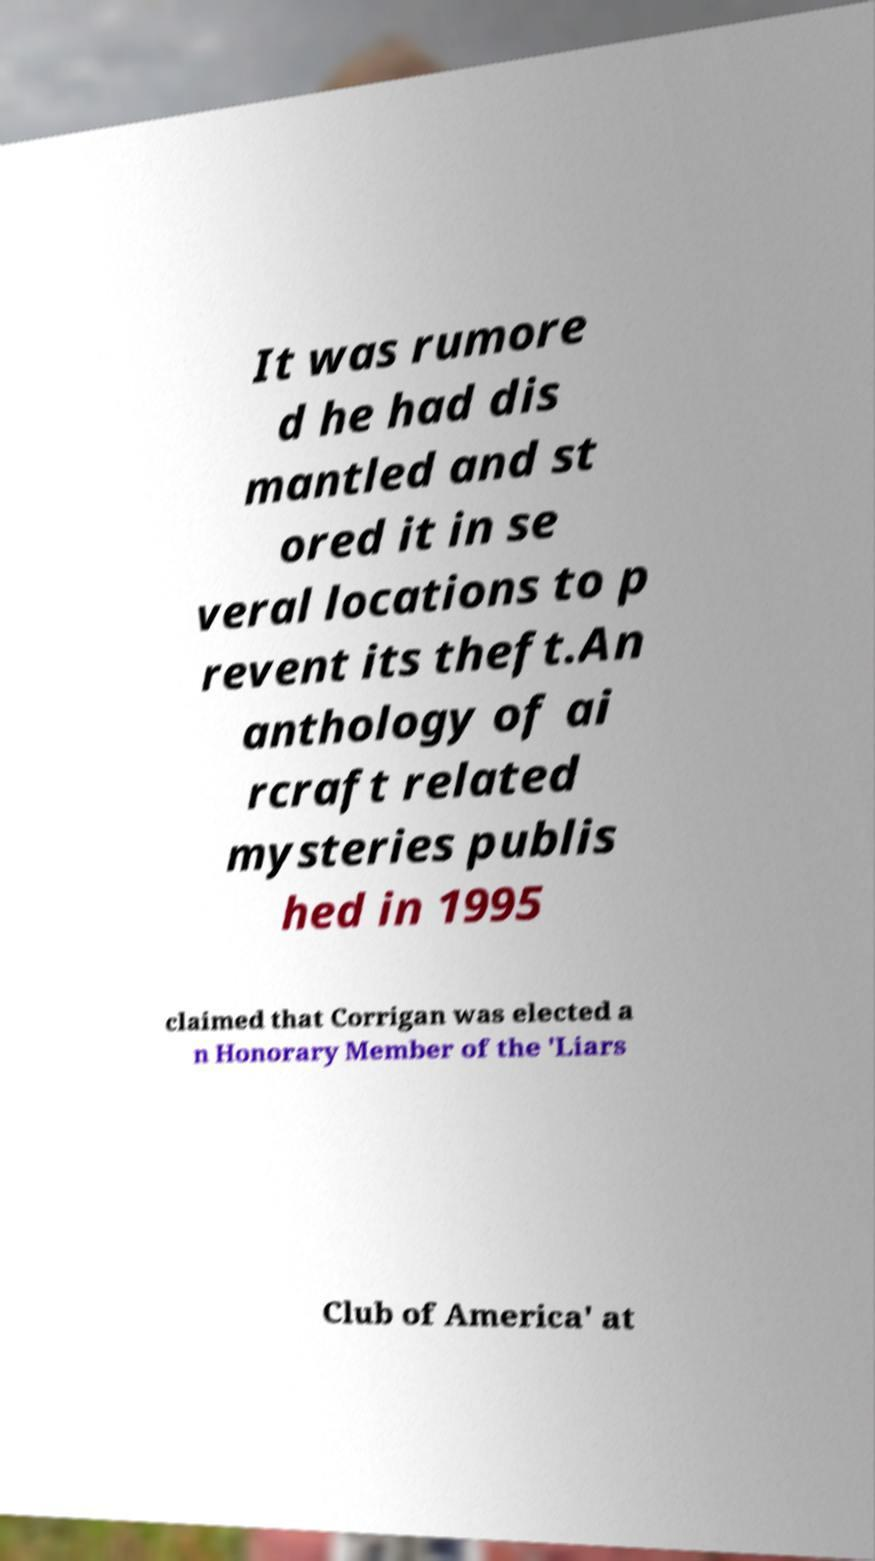For documentation purposes, I need the text within this image transcribed. Could you provide that? It was rumore d he had dis mantled and st ored it in se veral locations to p revent its theft.An anthology of ai rcraft related mysteries publis hed in 1995 claimed that Corrigan was elected a n Honorary Member of the 'Liars Club of America' at 